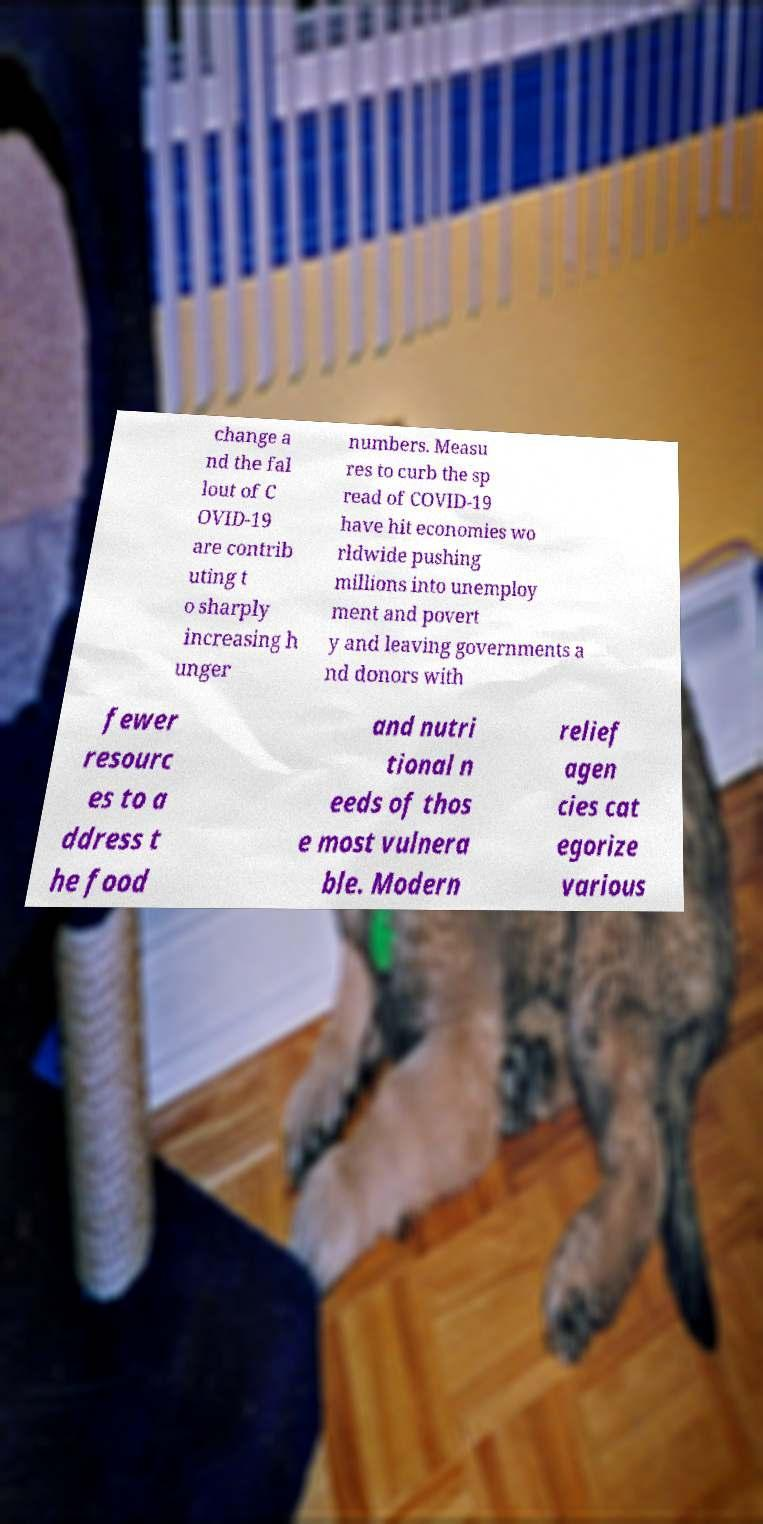Please identify and transcribe the text found in this image. change a nd the fal lout of C OVID-19 are contrib uting t o sharply increasing h unger numbers. Measu res to curb the sp read of COVID-19 have hit economies wo rldwide pushing millions into unemploy ment and povert y and leaving governments a nd donors with fewer resourc es to a ddress t he food and nutri tional n eeds of thos e most vulnera ble. Modern relief agen cies cat egorize various 